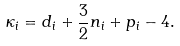Convert formula to latex. <formula><loc_0><loc_0><loc_500><loc_500>\kappa _ { i } = d _ { i } + \frac { 3 } { 2 } n _ { i } + p _ { i } - 4 .</formula> 